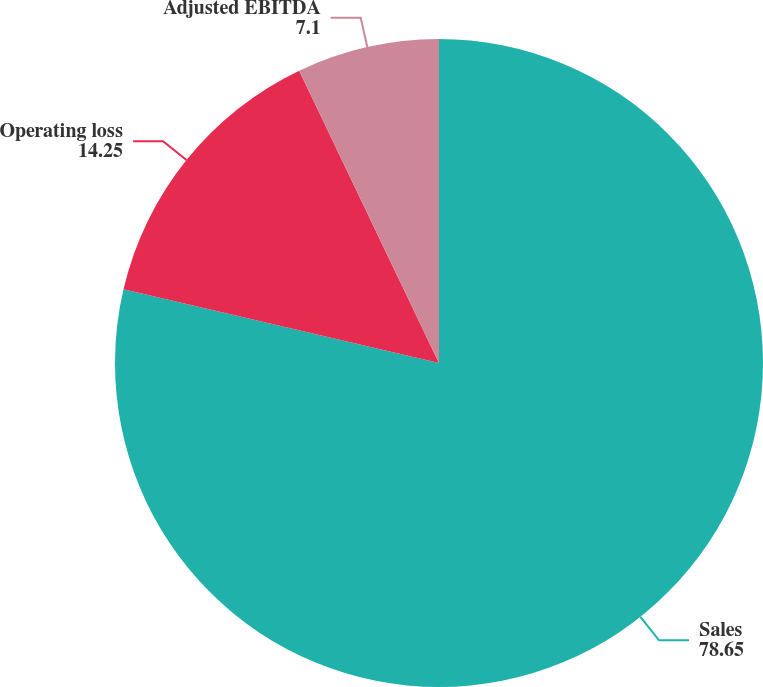Convert chart to OTSL. <chart><loc_0><loc_0><loc_500><loc_500><pie_chart><fcel>Sales<fcel>Operating loss<fcel>Adjusted EBITDA<nl><fcel>78.65%<fcel>14.25%<fcel>7.1%<nl></chart> 